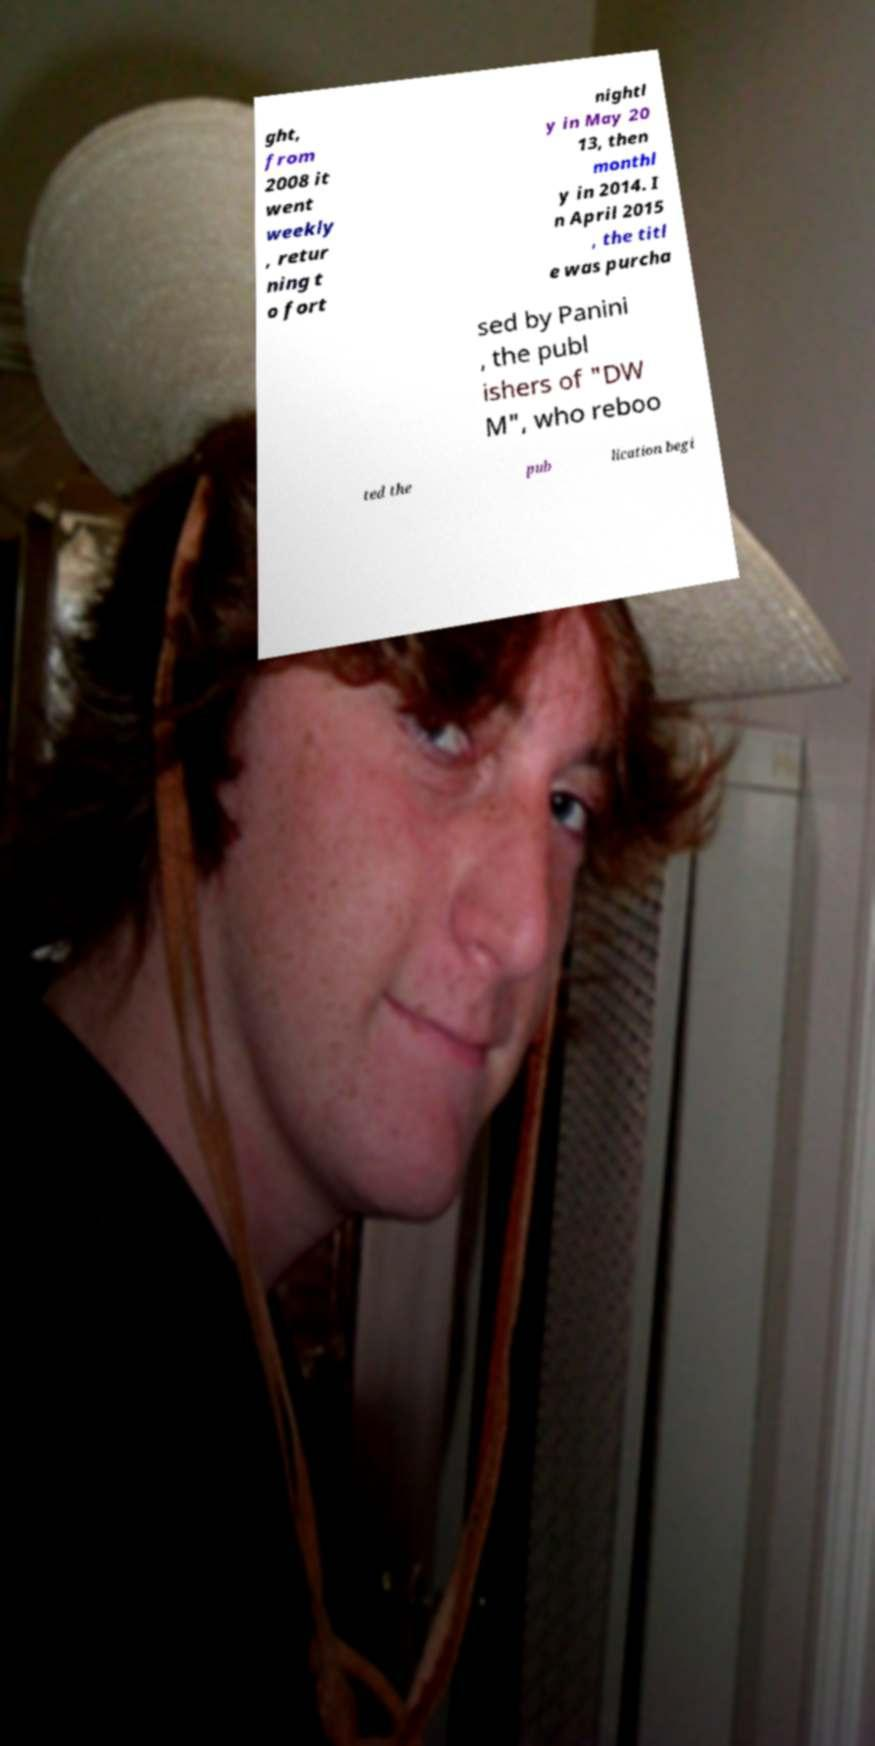What messages or text are displayed in this image? I need them in a readable, typed format. ght, from 2008 it went weekly , retur ning t o fort nightl y in May 20 13, then monthl y in 2014. I n April 2015 , the titl e was purcha sed by Panini , the publ ishers of "DW M", who reboo ted the pub lication begi 